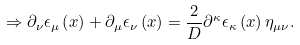Convert formula to latex. <formula><loc_0><loc_0><loc_500><loc_500>\Rightarrow \partial _ { \nu } \epsilon _ { \mu } \left ( x \right ) + \partial _ { \mu } \epsilon _ { \nu } \left ( x \right ) = \frac { 2 } { D } \partial ^ { \kappa } \epsilon _ { \kappa } \left ( x \right ) \eta _ { \mu \nu } .</formula> 